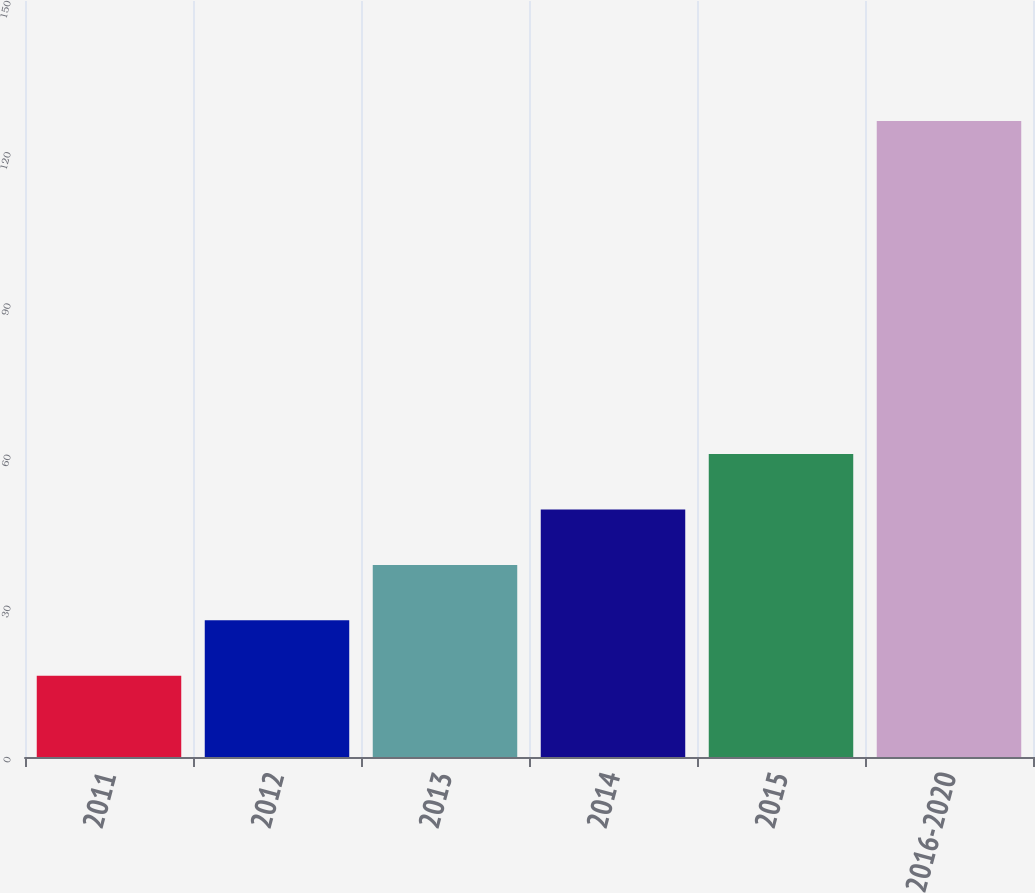Convert chart to OTSL. <chart><loc_0><loc_0><loc_500><loc_500><bar_chart><fcel>2011<fcel>2012<fcel>2013<fcel>2014<fcel>2015<fcel>2016-2020<nl><fcel>16.1<fcel>27.11<fcel>38.12<fcel>49.13<fcel>60.14<fcel>126.2<nl></chart> 